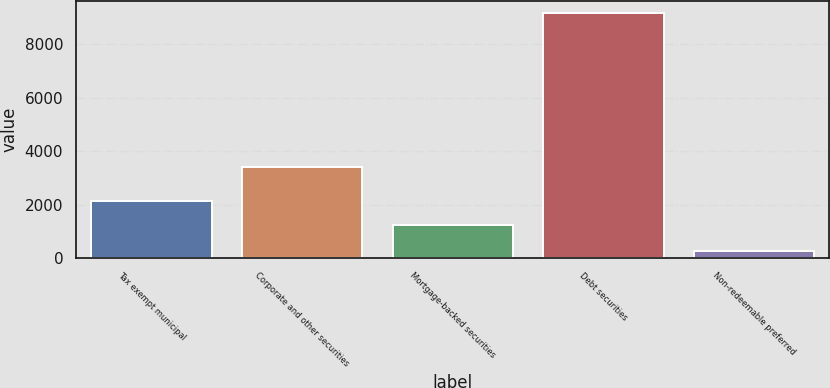Convert chart to OTSL. <chart><loc_0><loc_0><loc_500><loc_500><bar_chart><fcel>Tax exempt municipal<fcel>Corporate and other securities<fcel>Mortgage-backed securities<fcel>Debt securities<fcel>Non-redeemable preferred<nl><fcel>2142<fcel>3407<fcel>1251<fcel>9182<fcel>272<nl></chart> 